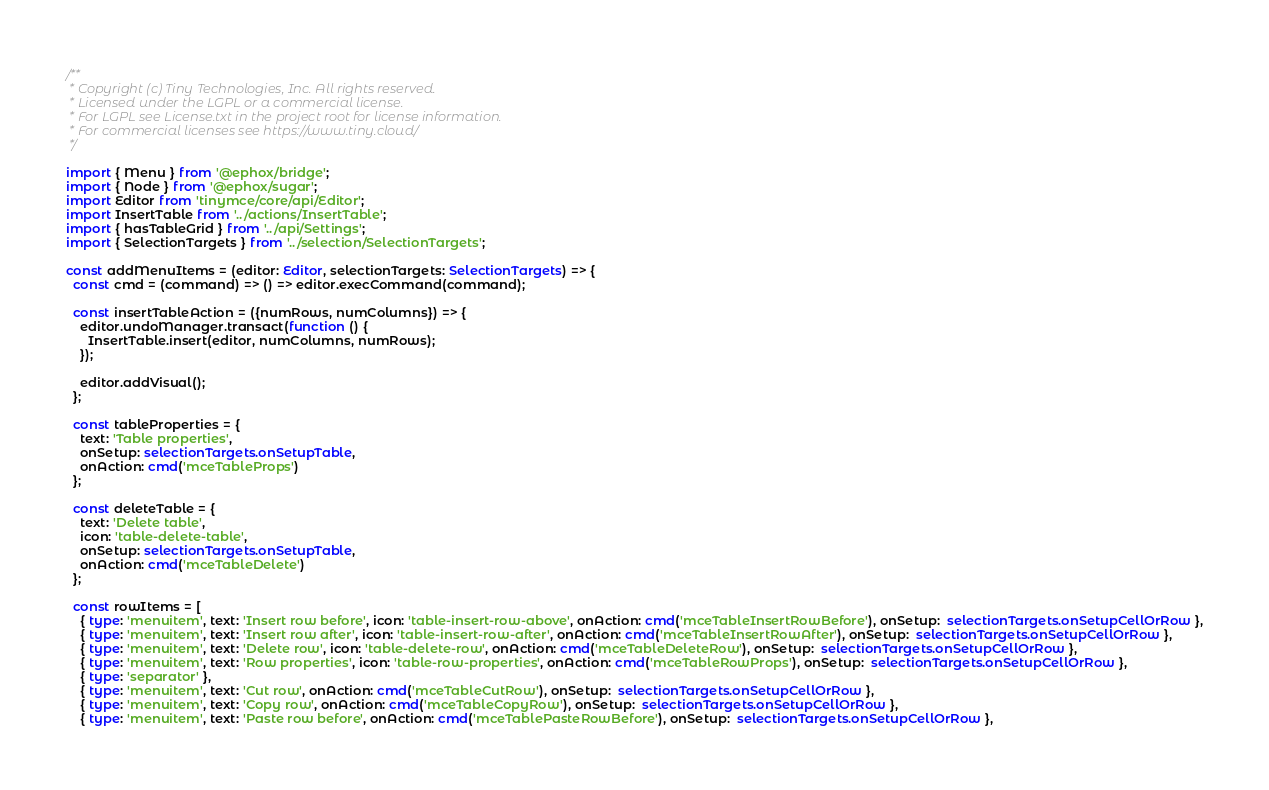<code> <loc_0><loc_0><loc_500><loc_500><_TypeScript_>/**
 * Copyright (c) Tiny Technologies, Inc. All rights reserved.
 * Licensed under the LGPL or a commercial license.
 * For LGPL see License.txt in the project root for license information.
 * For commercial licenses see https://www.tiny.cloud/
 */

import { Menu } from '@ephox/bridge';
import { Node } from '@ephox/sugar';
import Editor from 'tinymce/core/api/Editor';
import InsertTable from '../actions/InsertTable';
import { hasTableGrid } from '../api/Settings';
import { SelectionTargets } from '../selection/SelectionTargets';

const addMenuItems = (editor: Editor, selectionTargets: SelectionTargets) => {
  const cmd = (command) => () => editor.execCommand(command);

  const insertTableAction = ({numRows, numColumns}) => {
    editor.undoManager.transact(function () {
      InsertTable.insert(editor, numColumns, numRows);
    });

    editor.addVisual();
  };

  const tableProperties = {
    text: 'Table properties',
    onSetup: selectionTargets.onSetupTable,
    onAction: cmd('mceTableProps')
  };

  const deleteTable = {
    text: 'Delete table',
    icon: 'table-delete-table',
    onSetup: selectionTargets.onSetupTable,
    onAction: cmd('mceTableDelete')
  };

  const rowItems = [
    { type: 'menuitem', text: 'Insert row before', icon: 'table-insert-row-above', onAction: cmd('mceTableInsertRowBefore'), onSetup:  selectionTargets.onSetupCellOrRow },
    { type: 'menuitem', text: 'Insert row after', icon: 'table-insert-row-after', onAction: cmd('mceTableInsertRowAfter'), onSetup:  selectionTargets.onSetupCellOrRow },
    { type: 'menuitem', text: 'Delete row', icon: 'table-delete-row', onAction: cmd('mceTableDeleteRow'), onSetup:  selectionTargets.onSetupCellOrRow },
    { type: 'menuitem', text: 'Row properties', icon: 'table-row-properties', onAction: cmd('mceTableRowProps'), onSetup:  selectionTargets.onSetupCellOrRow },
    { type: 'separator' },
    { type: 'menuitem', text: 'Cut row', onAction: cmd('mceTableCutRow'), onSetup:  selectionTargets.onSetupCellOrRow },
    { type: 'menuitem', text: 'Copy row', onAction: cmd('mceTableCopyRow'), onSetup:  selectionTargets.onSetupCellOrRow },
    { type: 'menuitem', text: 'Paste row before', onAction: cmd('mceTablePasteRowBefore'), onSetup:  selectionTargets.onSetupCellOrRow },</code> 